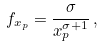Convert formula to latex. <formula><loc_0><loc_0><loc_500><loc_500>f _ { x _ { p } } = \frac { \sigma } { x _ { p } ^ { \sigma + 1 } } \, ,</formula> 